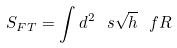<formula> <loc_0><loc_0><loc_500><loc_500>S _ { F T } = \int d ^ { 2 } \ s \sqrt { h } \ f R</formula> 